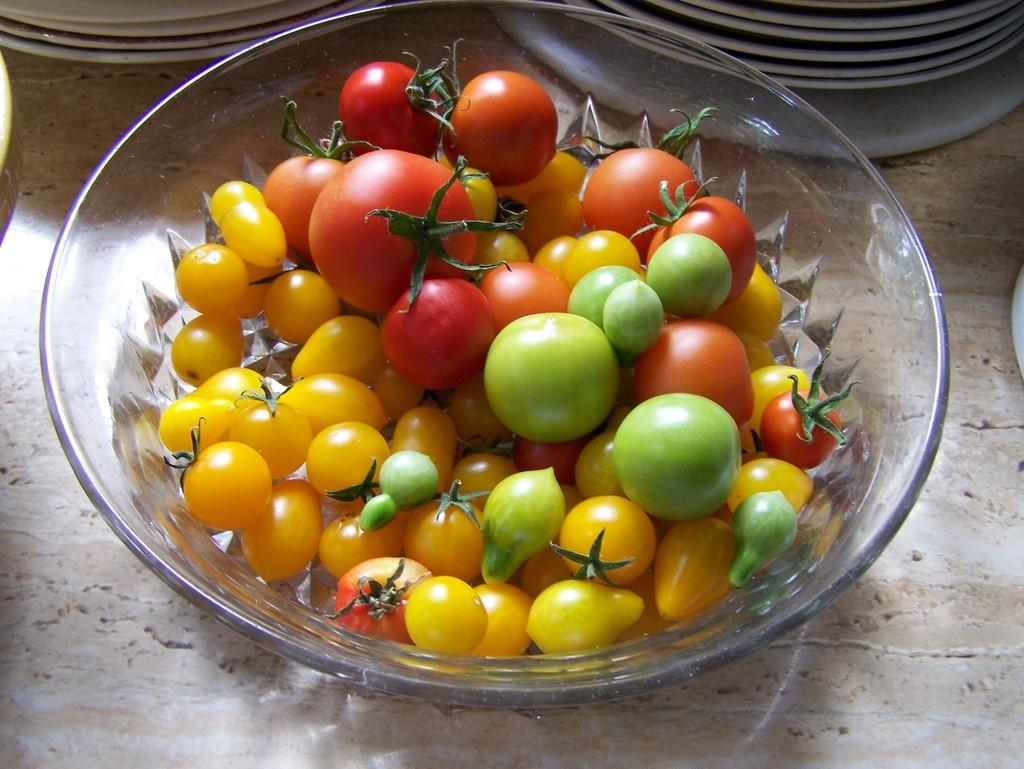What type of food is in the bowl in the image? There are tomatoes in a bowl in the image. What else can be seen in the image besides the bowl of tomatoes? There are plates visible in the image. Can you describe the surface on which the bowl and plates are placed? It is likely that there is a table in the image, as it is a common surface for holding food and dishes. What type of jelly is being used to extinguish the fire in the image? There is no fire or jelly present in the image; it only features tomatoes in a bowl and plates. 